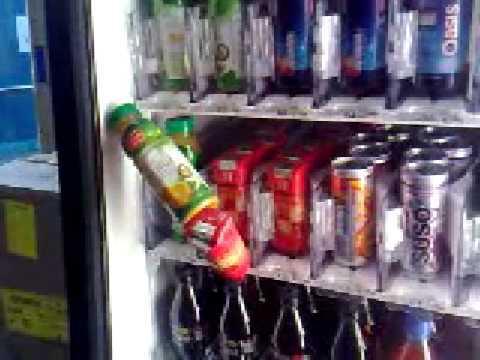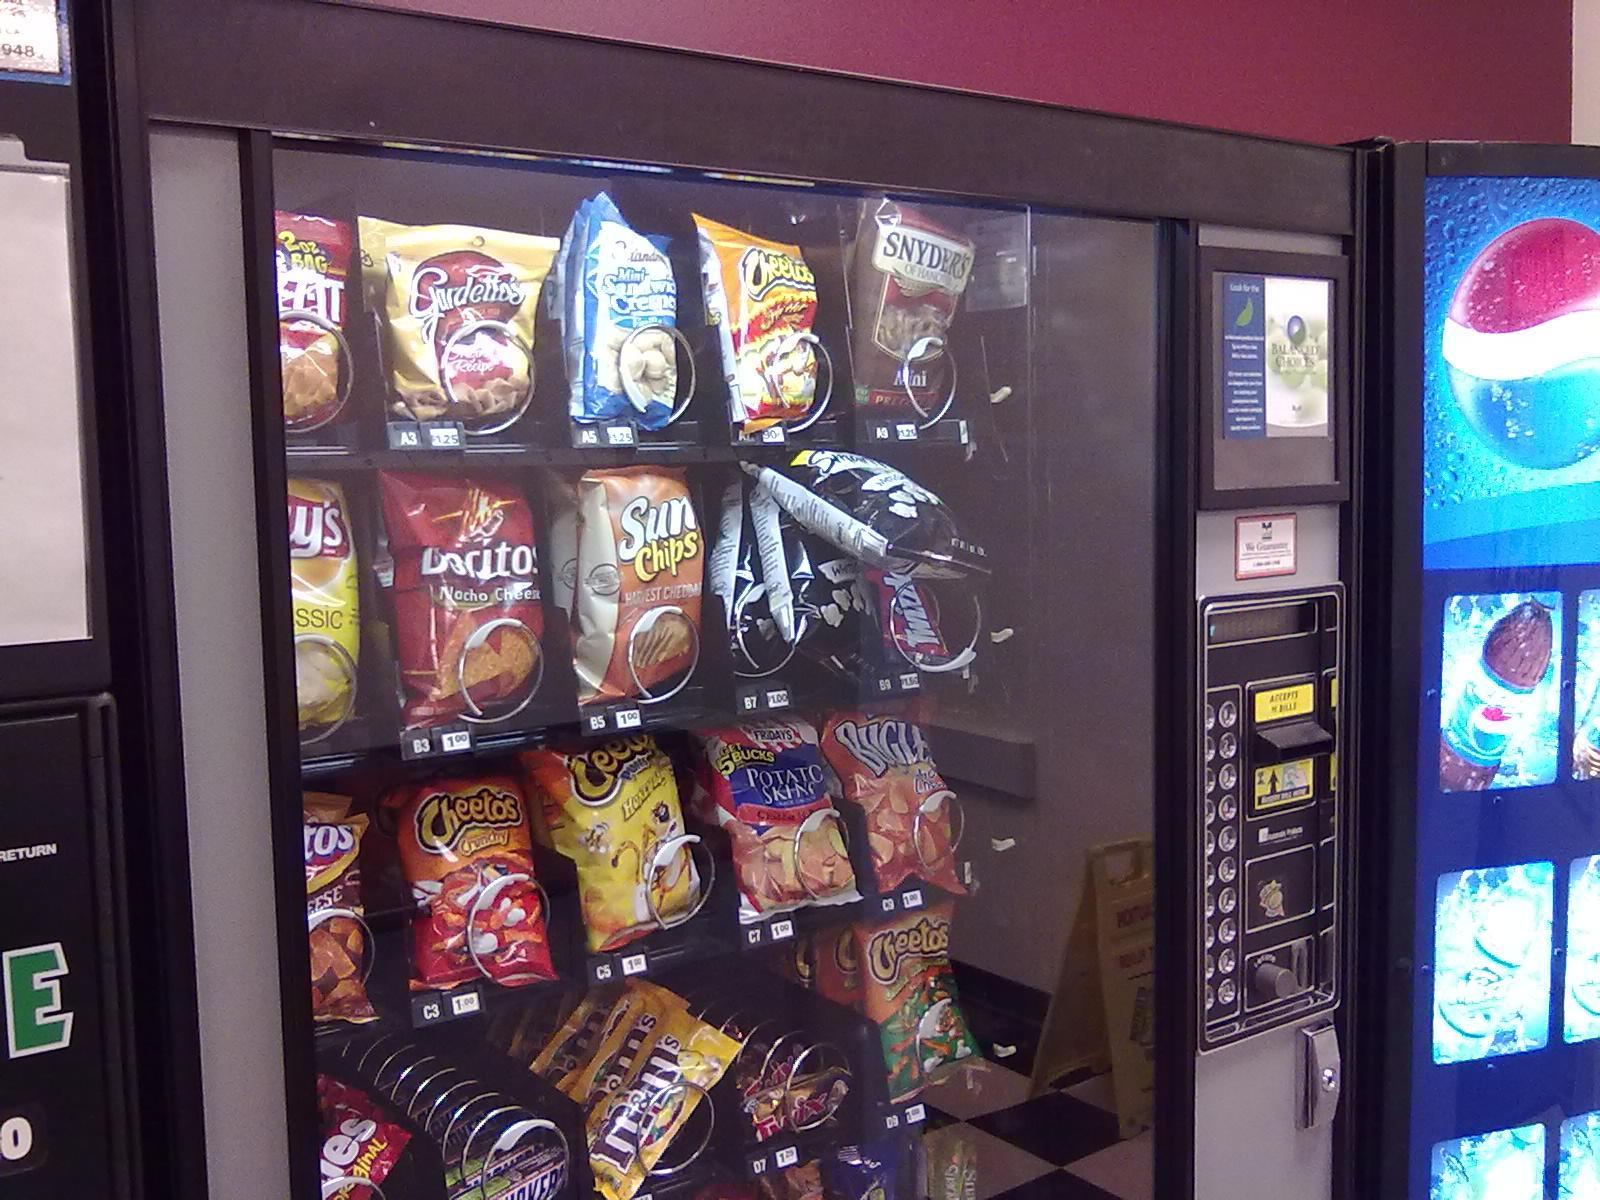The first image is the image on the left, the second image is the image on the right. Assess this claim about the two images: "At least one pack of peanut m&m's is in a vending machine in one of the images.". Correct or not? Answer yes or no. Yes. The first image is the image on the left, the second image is the image on the right. Considering the images on both sides, is "One image shows a vending machine front with one bottle at a diagonal, as if falling." valid? Answer yes or no. Yes. 